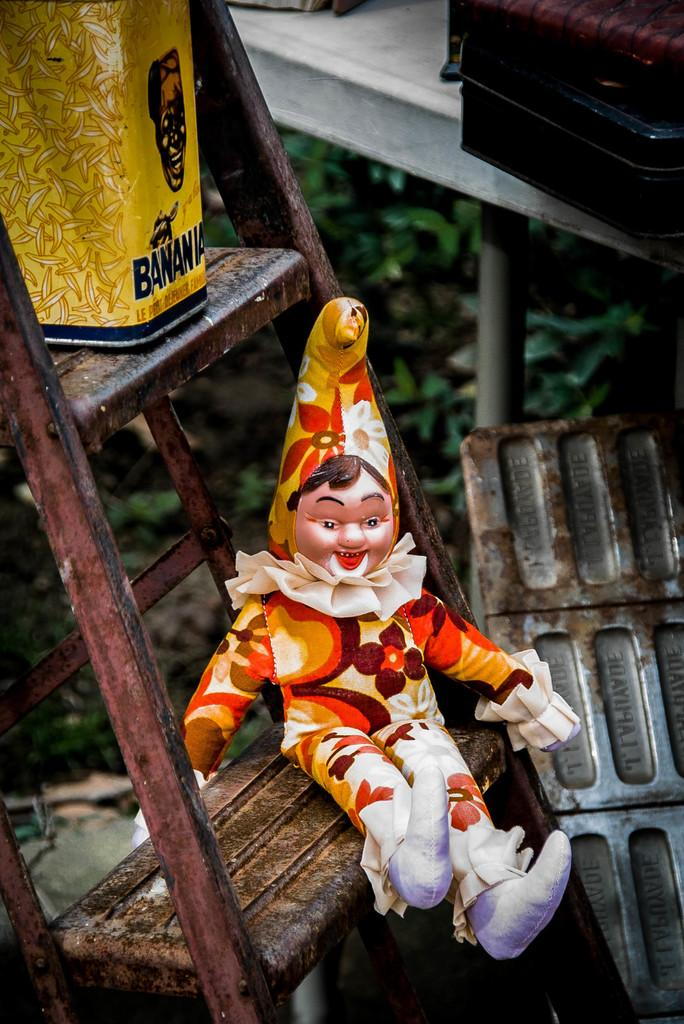What is the doll doing in the image? The doll is on a ladder in the image. What can be seen in the top left hand side of the image? There is a tin in the top left hand side of the image. What type of vegetation is visible in the background of the image? There are plants in the background of the image. What type of apple is hanging from the ladder in the image? There is no apple present in the image; it features a doll on a ladder and a tin in the top left hand side of the image. 